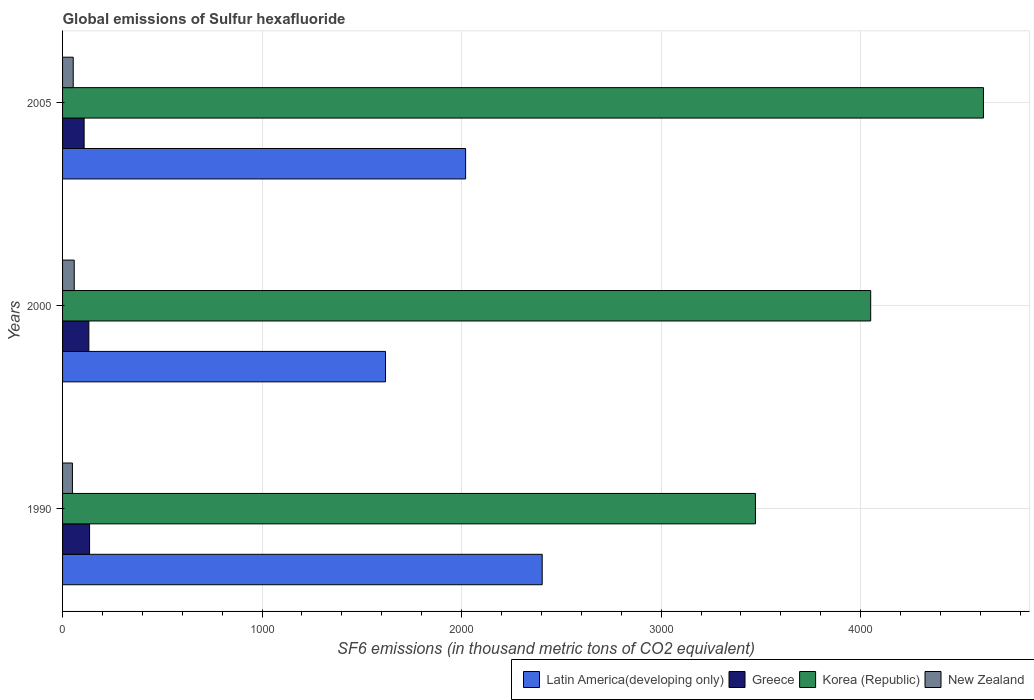How many different coloured bars are there?
Ensure brevity in your answer.  4. Are the number of bars per tick equal to the number of legend labels?
Provide a short and direct response. Yes. How many bars are there on the 3rd tick from the top?
Give a very brief answer. 4. What is the global emissions of Sulfur hexafluoride in New Zealand in 1990?
Offer a very short reply. 49.4. Across all years, what is the maximum global emissions of Sulfur hexafluoride in Greece?
Your answer should be compact. 135.4. Across all years, what is the minimum global emissions of Sulfur hexafluoride in New Zealand?
Your response must be concise. 49.4. In which year was the global emissions of Sulfur hexafluoride in Latin America(developing only) minimum?
Offer a very short reply. 2000. What is the total global emissions of Sulfur hexafluoride in Korea (Republic) in the graph?
Make the answer very short. 1.21e+04. What is the difference between the global emissions of Sulfur hexafluoride in Korea (Republic) in 1990 and that in 2000?
Provide a succinct answer. -577.6. What is the difference between the global emissions of Sulfur hexafluoride in Korea (Republic) in 1990 and the global emissions of Sulfur hexafluoride in New Zealand in 2000?
Provide a succinct answer. 3414.5. What is the average global emissions of Sulfur hexafluoride in Latin America(developing only) per year?
Provide a succinct answer. 2014.32. In the year 2000, what is the difference between the global emissions of Sulfur hexafluoride in Greece and global emissions of Sulfur hexafluoride in Latin America(developing only)?
Your answer should be compact. -1486.9. In how many years, is the global emissions of Sulfur hexafluoride in Latin America(developing only) greater than 1800 thousand metric tons?
Provide a succinct answer. 2. What is the ratio of the global emissions of Sulfur hexafluoride in Korea (Republic) in 1990 to that in 2000?
Offer a terse response. 0.86. Is the difference between the global emissions of Sulfur hexafluoride in Greece in 1990 and 2000 greater than the difference between the global emissions of Sulfur hexafluoride in Latin America(developing only) in 1990 and 2000?
Your answer should be compact. No. What is the difference between the highest and the second highest global emissions of Sulfur hexafluoride in Latin America(developing only)?
Ensure brevity in your answer.  383.94. What is the difference between the highest and the lowest global emissions of Sulfur hexafluoride in Latin America(developing only)?
Your answer should be very brief. 785.4. Is the sum of the global emissions of Sulfur hexafluoride in Korea (Republic) in 1990 and 2005 greater than the maximum global emissions of Sulfur hexafluoride in New Zealand across all years?
Your answer should be compact. Yes. What does the 2nd bar from the top in 2005 represents?
Offer a very short reply. Korea (Republic). What does the 1st bar from the bottom in 1990 represents?
Your answer should be very brief. Latin America(developing only). Is it the case that in every year, the sum of the global emissions of Sulfur hexafluoride in Greece and global emissions of Sulfur hexafluoride in New Zealand is greater than the global emissions of Sulfur hexafluoride in Korea (Republic)?
Give a very brief answer. No. Are all the bars in the graph horizontal?
Provide a succinct answer. Yes. What is the difference between two consecutive major ticks on the X-axis?
Your answer should be very brief. 1000. Are the values on the major ticks of X-axis written in scientific E-notation?
Keep it short and to the point. No. Where does the legend appear in the graph?
Keep it short and to the point. Bottom right. How many legend labels are there?
Offer a very short reply. 4. What is the title of the graph?
Keep it short and to the point. Global emissions of Sulfur hexafluoride. Does "Slovak Republic" appear as one of the legend labels in the graph?
Make the answer very short. No. What is the label or title of the X-axis?
Your answer should be compact. SF6 emissions (in thousand metric tons of CO2 equivalent). What is the label or title of the Y-axis?
Give a very brief answer. Years. What is the SF6 emissions (in thousand metric tons of CO2 equivalent) in Latin America(developing only) in 1990?
Provide a succinct answer. 2404.1. What is the SF6 emissions (in thousand metric tons of CO2 equivalent) in Greece in 1990?
Your answer should be very brief. 135.4. What is the SF6 emissions (in thousand metric tons of CO2 equivalent) in Korea (Republic) in 1990?
Your answer should be compact. 3472.9. What is the SF6 emissions (in thousand metric tons of CO2 equivalent) in New Zealand in 1990?
Make the answer very short. 49.4. What is the SF6 emissions (in thousand metric tons of CO2 equivalent) in Latin America(developing only) in 2000?
Your response must be concise. 1618.7. What is the SF6 emissions (in thousand metric tons of CO2 equivalent) of Greece in 2000?
Offer a terse response. 131.8. What is the SF6 emissions (in thousand metric tons of CO2 equivalent) of Korea (Republic) in 2000?
Provide a succinct answer. 4050.5. What is the SF6 emissions (in thousand metric tons of CO2 equivalent) of New Zealand in 2000?
Keep it short and to the point. 58.4. What is the SF6 emissions (in thousand metric tons of CO2 equivalent) in Latin America(developing only) in 2005?
Ensure brevity in your answer.  2020.16. What is the SF6 emissions (in thousand metric tons of CO2 equivalent) in Greece in 2005?
Make the answer very short. 108.1. What is the SF6 emissions (in thousand metric tons of CO2 equivalent) of Korea (Republic) in 2005?
Your answer should be very brief. 4615.7. What is the SF6 emissions (in thousand metric tons of CO2 equivalent) of New Zealand in 2005?
Offer a terse response. 53.4. Across all years, what is the maximum SF6 emissions (in thousand metric tons of CO2 equivalent) in Latin America(developing only)?
Keep it short and to the point. 2404.1. Across all years, what is the maximum SF6 emissions (in thousand metric tons of CO2 equivalent) in Greece?
Offer a terse response. 135.4. Across all years, what is the maximum SF6 emissions (in thousand metric tons of CO2 equivalent) in Korea (Republic)?
Keep it short and to the point. 4615.7. Across all years, what is the maximum SF6 emissions (in thousand metric tons of CO2 equivalent) of New Zealand?
Offer a very short reply. 58.4. Across all years, what is the minimum SF6 emissions (in thousand metric tons of CO2 equivalent) in Latin America(developing only)?
Your response must be concise. 1618.7. Across all years, what is the minimum SF6 emissions (in thousand metric tons of CO2 equivalent) in Greece?
Offer a terse response. 108.1. Across all years, what is the minimum SF6 emissions (in thousand metric tons of CO2 equivalent) in Korea (Republic)?
Offer a very short reply. 3472.9. Across all years, what is the minimum SF6 emissions (in thousand metric tons of CO2 equivalent) of New Zealand?
Your answer should be very brief. 49.4. What is the total SF6 emissions (in thousand metric tons of CO2 equivalent) in Latin America(developing only) in the graph?
Offer a very short reply. 6042.96. What is the total SF6 emissions (in thousand metric tons of CO2 equivalent) of Greece in the graph?
Ensure brevity in your answer.  375.3. What is the total SF6 emissions (in thousand metric tons of CO2 equivalent) in Korea (Republic) in the graph?
Provide a short and direct response. 1.21e+04. What is the total SF6 emissions (in thousand metric tons of CO2 equivalent) of New Zealand in the graph?
Your answer should be compact. 161.2. What is the difference between the SF6 emissions (in thousand metric tons of CO2 equivalent) of Latin America(developing only) in 1990 and that in 2000?
Ensure brevity in your answer.  785.4. What is the difference between the SF6 emissions (in thousand metric tons of CO2 equivalent) of Korea (Republic) in 1990 and that in 2000?
Provide a succinct answer. -577.6. What is the difference between the SF6 emissions (in thousand metric tons of CO2 equivalent) in New Zealand in 1990 and that in 2000?
Keep it short and to the point. -9. What is the difference between the SF6 emissions (in thousand metric tons of CO2 equivalent) in Latin America(developing only) in 1990 and that in 2005?
Provide a short and direct response. 383.94. What is the difference between the SF6 emissions (in thousand metric tons of CO2 equivalent) in Greece in 1990 and that in 2005?
Give a very brief answer. 27.3. What is the difference between the SF6 emissions (in thousand metric tons of CO2 equivalent) in Korea (Republic) in 1990 and that in 2005?
Provide a succinct answer. -1142.8. What is the difference between the SF6 emissions (in thousand metric tons of CO2 equivalent) of New Zealand in 1990 and that in 2005?
Offer a terse response. -4. What is the difference between the SF6 emissions (in thousand metric tons of CO2 equivalent) of Latin America(developing only) in 2000 and that in 2005?
Make the answer very short. -401.46. What is the difference between the SF6 emissions (in thousand metric tons of CO2 equivalent) of Greece in 2000 and that in 2005?
Ensure brevity in your answer.  23.7. What is the difference between the SF6 emissions (in thousand metric tons of CO2 equivalent) of Korea (Republic) in 2000 and that in 2005?
Offer a very short reply. -565.2. What is the difference between the SF6 emissions (in thousand metric tons of CO2 equivalent) in Latin America(developing only) in 1990 and the SF6 emissions (in thousand metric tons of CO2 equivalent) in Greece in 2000?
Provide a succinct answer. 2272.3. What is the difference between the SF6 emissions (in thousand metric tons of CO2 equivalent) in Latin America(developing only) in 1990 and the SF6 emissions (in thousand metric tons of CO2 equivalent) in Korea (Republic) in 2000?
Ensure brevity in your answer.  -1646.4. What is the difference between the SF6 emissions (in thousand metric tons of CO2 equivalent) of Latin America(developing only) in 1990 and the SF6 emissions (in thousand metric tons of CO2 equivalent) of New Zealand in 2000?
Make the answer very short. 2345.7. What is the difference between the SF6 emissions (in thousand metric tons of CO2 equivalent) in Greece in 1990 and the SF6 emissions (in thousand metric tons of CO2 equivalent) in Korea (Republic) in 2000?
Give a very brief answer. -3915.1. What is the difference between the SF6 emissions (in thousand metric tons of CO2 equivalent) of Greece in 1990 and the SF6 emissions (in thousand metric tons of CO2 equivalent) of New Zealand in 2000?
Make the answer very short. 77. What is the difference between the SF6 emissions (in thousand metric tons of CO2 equivalent) in Korea (Republic) in 1990 and the SF6 emissions (in thousand metric tons of CO2 equivalent) in New Zealand in 2000?
Your answer should be very brief. 3414.5. What is the difference between the SF6 emissions (in thousand metric tons of CO2 equivalent) in Latin America(developing only) in 1990 and the SF6 emissions (in thousand metric tons of CO2 equivalent) in Greece in 2005?
Your response must be concise. 2296. What is the difference between the SF6 emissions (in thousand metric tons of CO2 equivalent) of Latin America(developing only) in 1990 and the SF6 emissions (in thousand metric tons of CO2 equivalent) of Korea (Republic) in 2005?
Provide a short and direct response. -2211.6. What is the difference between the SF6 emissions (in thousand metric tons of CO2 equivalent) of Latin America(developing only) in 1990 and the SF6 emissions (in thousand metric tons of CO2 equivalent) of New Zealand in 2005?
Your answer should be compact. 2350.7. What is the difference between the SF6 emissions (in thousand metric tons of CO2 equivalent) in Greece in 1990 and the SF6 emissions (in thousand metric tons of CO2 equivalent) in Korea (Republic) in 2005?
Offer a very short reply. -4480.3. What is the difference between the SF6 emissions (in thousand metric tons of CO2 equivalent) in Greece in 1990 and the SF6 emissions (in thousand metric tons of CO2 equivalent) in New Zealand in 2005?
Your answer should be compact. 82. What is the difference between the SF6 emissions (in thousand metric tons of CO2 equivalent) in Korea (Republic) in 1990 and the SF6 emissions (in thousand metric tons of CO2 equivalent) in New Zealand in 2005?
Give a very brief answer. 3419.5. What is the difference between the SF6 emissions (in thousand metric tons of CO2 equivalent) in Latin America(developing only) in 2000 and the SF6 emissions (in thousand metric tons of CO2 equivalent) in Greece in 2005?
Make the answer very short. 1510.6. What is the difference between the SF6 emissions (in thousand metric tons of CO2 equivalent) of Latin America(developing only) in 2000 and the SF6 emissions (in thousand metric tons of CO2 equivalent) of Korea (Republic) in 2005?
Keep it short and to the point. -2997. What is the difference between the SF6 emissions (in thousand metric tons of CO2 equivalent) of Latin America(developing only) in 2000 and the SF6 emissions (in thousand metric tons of CO2 equivalent) of New Zealand in 2005?
Ensure brevity in your answer.  1565.3. What is the difference between the SF6 emissions (in thousand metric tons of CO2 equivalent) of Greece in 2000 and the SF6 emissions (in thousand metric tons of CO2 equivalent) of Korea (Republic) in 2005?
Make the answer very short. -4483.9. What is the difference between the SF6 emissions (in thousand metric tons of CO2 equivalent) of Greece in 2000 and the SF6 emissions (in thousand metric tons of CO2 equivalent) of New Zealand in 2005?
Give a very brief answer. 78.4. What is the difference between the SF6 emissions (in thousand metric tons of CO2 equivalent) of Korea (Republic) in 2000 and the SF6 emissions (in thousand metric tons of CO2 equivalent) of New Zealand in 2005?
Your response must be concise. 3997.1. What is the average SF6 emissions (in thousand metric tons of CO2 equivalent) of Latin America(developing only) per year?
Your answer should be compact. 2014.32. What is the average SF6 emissions (in thousand metric tons of CO2 equivalent) in Greece per year?
Your answer should be very brief. 125.1. What is the average SF6 emissions (in thousand metric tons of CO2 equivalent) in Korea (Republic) per year?
Keep it short and to the point. 4046.37. What is the average SF6 emissions (in thousand metric tons of CO2 equivalent) of New Zealand per year?
Your answer should be very brief. 53.73. In the year 1990, what is the difference between the SF6 emissions (in thousand metric tons of CO2 equivalent) in Latin America(developing only) and SF6 emissions (in thousand metric tons of CO2 equivalent) in Greece?
Offer a terse response. 2268.7. In the year 1990, what is the difference between the SF6 emissions (in thousand metric tons of CO2 equivalent) of Latin America(developing only) and SF6 emissions (in thousand metric tons of CO2 equivalent) of Korea (Republic)?
Offer a very short reply. -1068.8. In the year 1990, what is the difference between the SF6 emissions (in thousand metric tons of CO2 equivalent) in Latin America(developing only) and SF6 emissions (in thousand metric tons of CO2 equivalent) in New Zealand?
Provide a short and direct response. 2354.7. In the year 1990, what is the difference between the SF6 emissions (in thousand metric tons of CO2 equivalent) in Greece and SF6 emissions (in thousand metric tons of CO2 equivalent) in Korea (Republic)?
Provide a short and direct response. -3337.5. In the year 1990, what is the difference between the SF6 emissions (in thousand metric tons of CO2 equivalent) in Korea (Republic) and SF6 emissions (in thousand metric tons of CO2 equivalent) in New Zealand?
Your response must be concise. 3423.5. In the year 2000, what is the difference between the SF6 emissions (in thousand metric tons of CO2 equivalent) of Latin America(developing only) and SF6 emissions (in thousand metric tons of CO2 equivalent) of Greece?
Offer a very short reply. 1486.9. In the year 2000, what is the difference between the SF6 emissions (in thousand metric tons of CO2 equivalent) of Latin America(developing only) and SF6 emissions (in thousand metric tons of CO2 equivalent) of Korea (Republic)?
Make the answer very short. -2431.8. In the year 2000, what is the difference between the SF6 emissions (in thousand metric tons of CO2 equivalent) of Latin America(developing only) and SF6 emissions (in thousand metric tons of CO2 equivalent) of New Zealand?
Provide a succinct answer. 1560.3. In the year 2000, what is the difference between the SF6 emissions (in thousand metric tons of CO2 equivalent) in Greece and SF6 emissions (in thousand metric tons of CO2 equivalent) in Korea (Republic)?
Provide a short and direct response. -3918.7. In the year 2000, what is the difference between the SF6 emissions (in thousand metric tons of CO2 equivalent) of Greece and SF6 emissions (in thousand metric tons of CO2 equivalent) of New Zealand?
Offer a terse response. 73.4. In the year 2000, what is the difference between the SF6 emissions (in thousand metric tons of CO2 equivalent) of Korea (Republic) and SF6 emissions (in thousand metric tons of CO2 equivalent) of New Zealand?
Your answer should be very brief. 3992.1. In the year 2005, what is the difference between the SF6 emissions (in thousand metric tons of CO2 equivalent) in Latin America(developing only) and SF6 emissions (in thousand metric tons of CO2 equivalent) in Greece?
Ensure brevity in your answer.  1912.06. In the year 2005, what is the difference between the SF6 emissions (in thousand metric tons of CO2 equivalent) in Latin America(developing only) and SF6 emissions (in thousand metric tons of CO2 equivalent) in Korea (Republic)?
Offer a terse response. -2595.54. In the year 2005, what is the difference between the SF6 emissions (in thousand metric tons of CO2 equivalent) in Latin America(developing only) and SF6 emissions (in thousand metric tons of CO2 equivalent) in New Zealand?
Ensure brevity in your answer.  1966.76. In the year 2005, what is the difference between the SF6 emissions (in thousand metric tons of CO2 equivalent) of Greece and SF6 emissions (in thousand metric tons of CO2 equivalent) of Korea (Republic)?
Ensure brevity in your answer.  -4507.6. In the year 2005, what is the difference between the SF6 emissions (in thousand metric tons of CO2 equivalent) in Greece and SF6 emissions (in thousand metric tons of CO2 equivalent) in New Zealand?
Ensure brevity in your answer.  54.7. In the year 2005, what is the difference between the SF6 emissions (in thousand metric tons of CO2 equivalent) in Korea (Republic) and SF6 emissions (in thousand metric tons of CO2 equivalent) in New Zealand?
Your answer should be very brief. 4562.3. What is the ratio of the SF6 emissions (in thousand metric tons of CO2 equivalent) in Latin America(developing only) in 1990 to that in 2000?
Your response must be concise. 1.49. What is the ratio of the SF6 emissions (in thousand metric tons of CO2 equivalent) in Greece in 1990 to that in 2000?
Provide a succinct answer. 1.03. What is the ratio of the SF6 emissions (in thousand metric tons of CO2 equivalent) of Korea (Republic) in 1990 to that in 2000?
Ensure brevity in your answer.  0.86. What is the ratio of the SF6 emissions (in thousand metric tons of CO2 equivalent) in New Zealand in 1990 to that in 2000?
Provide a succinct answer. 0.85. What is the ratio of the SF6 emissions (in thousand metric tons of CO2 equivalent) of Latin America(developing only) in 1990 to that in 2005?
Your answer should be very brief. 1.19. What is the ratio of the SF6 emissions (in thousand metric tons of CO2 equivalent) of Greece in 1990 to that in 2005?
Provide a short and direct response. 1.25. What is the ratio of the SF6 emissions (in thousand metric tons of CO2 equivalent) in Korea (Republic) in 1990 to that in 2005?
Your answer should be very brief. 0.75. What is the ratio of the SF6 emissions (in thousand metric tons of CO2 equivalent) in New Zealand in 1990 to that in 2005?
Your answer should be compact. 0.93. What is the ratio of the SF6 emissions (in thousand metric tons of CO2 equivalent) of Latin America(developing only) in 2000 to that in 2005?
Keep it short and to the point. 0.8. What is the ratio of the SF6 emissions (in thousand metric tons of CO2 equivalent) of Greece in 2000 to that in 2005?
Your answer should be compact. 1.22. What is the ratio of the SF6 emissions (in thousand metric tons of CO2 equivalent) in Korea (Republic) in 2000 to that in 2005?
Your answer should be very brief. 0.88. What is the ratio of the SF6 emissions (in thousand metric tons of CO2 equivalent) of New Zealand in 2000 to that in 2005?
Make the answer very short. 1.09. What is the difference between the highest and the second highest SF6 emissions (in thousand metric tons of CO2 equivalent) of Latin America(developing only)?
Offer a very short reply. 383.94. What is the difference between the highest and the second highest SF6 emissions (in thousand metric tons of CO2 equivalent) in Greece?
Provide a succinct answer. 3.6. What is the difference between the highest and the second highest SF6 emissions (in thousand metric tons of CO2 equivalent) of Korea (Republic)?
Your response must be concise. 565.2. What is the difference between the highest and the lowest SF6 emissions (in thousand metric tons of CO2 equivalent) of Latin America(developing only)?
Provide a succinct answer. 785.4. What is the difference between the highest and the lowest SF6 emissions (in thousand metric tons of CO2 equivalent) of Greece?
Provide a short and direct response. 27.3. What is the difference between the highest and the lowest SF6 emissions (in thousand metric tons of CO2 equivalent) in Korea (Republic)?
Your response must be concise. 1142.8. 